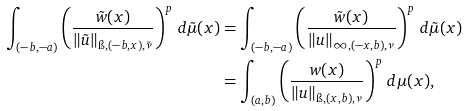<formula> <loc_0><loc_0><loc_500><loc_500>\int _ { ( - b , - a ) } \left ( \frac { \tilde { w } ( x ) } { \| \tilde { u } \| _ { \i , ( - b , x ) , \tilde { \nu } } } \right ) ^ { p } \, d \tilde { \mu } ( x ) & = \int _ { ( - b , - a ) } \left ( \frac { \tilde { w } ( x ) } { \| u \| _ { \infty , ( - x , b ) , \nu } } \right ) ^ { p } \, d \tilde { \mu } ( x ) \\ & = \int _ { ( a , b ) } \left ( \frac { w ( x ) } { \| u \| _ { \i , ( x , b ) , \nu } } \right ) ^ { p } \, d \mu ( x ) ,</formula> 